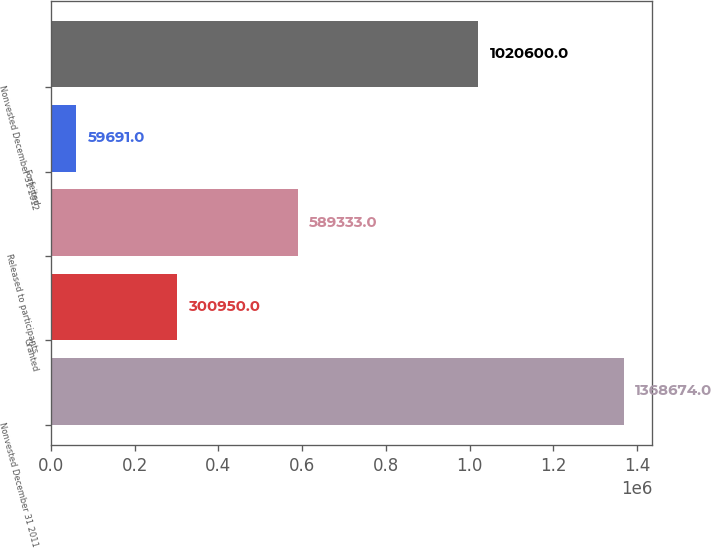Convert chart. <chart><loc_0><loc_0><loc_500><loc_500><bar_chart><fcel>Nonvested December 31 2011<fcel>Granted<fcel>Released to participants<fcel>Forfeited<fcel>Nonvested December 31 2012<nl><fcel>1.36867e+06<fcel>300950<fcel>589333<fcel>59691<fcel>1.0206e+06<nl></chart> 